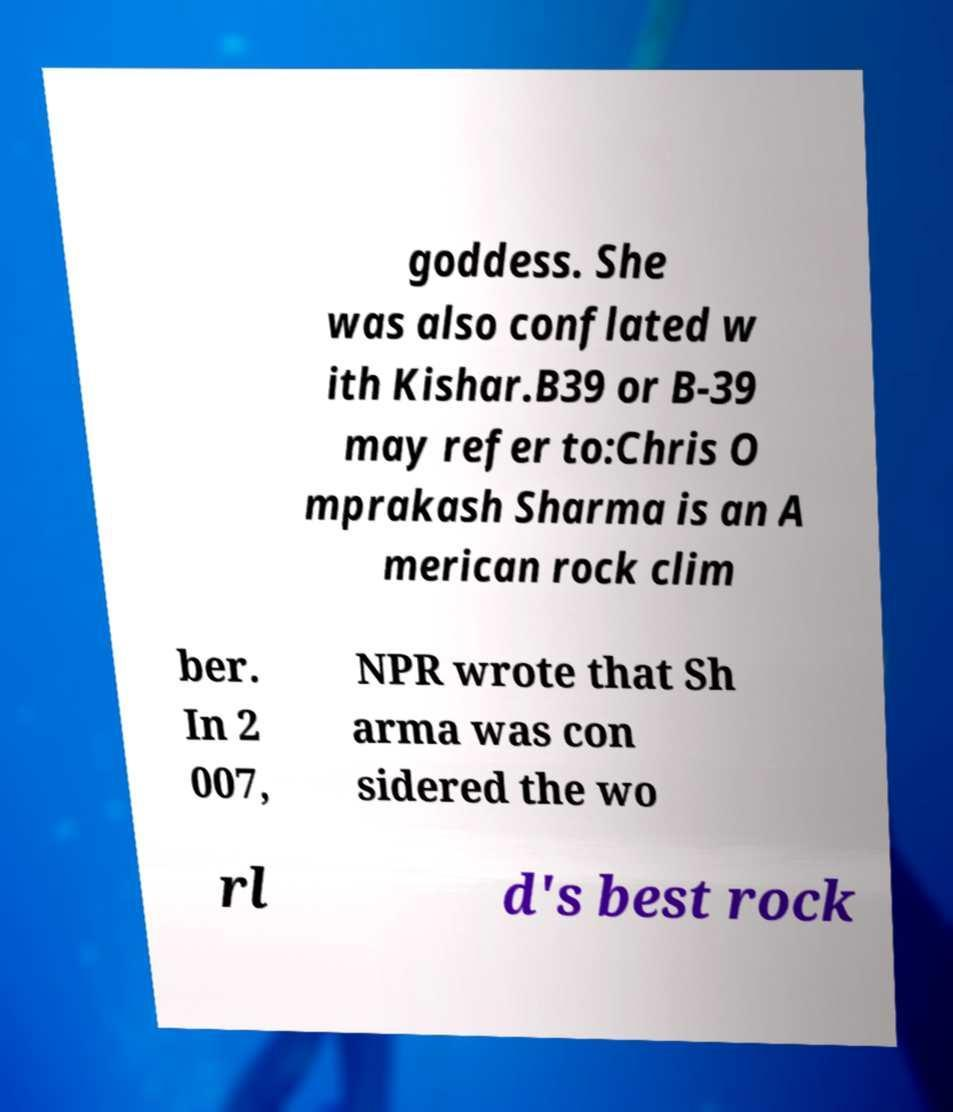Could you extract and type out the text from this image? goddess. She was also conflated w ith Kishar.B39 or B-39 may refer to:Chris O mprakash Sharma is an A merican rock clim ber. In 2 007, NPR wrote that Sh arma was con sidered the wo rl d's best rock 